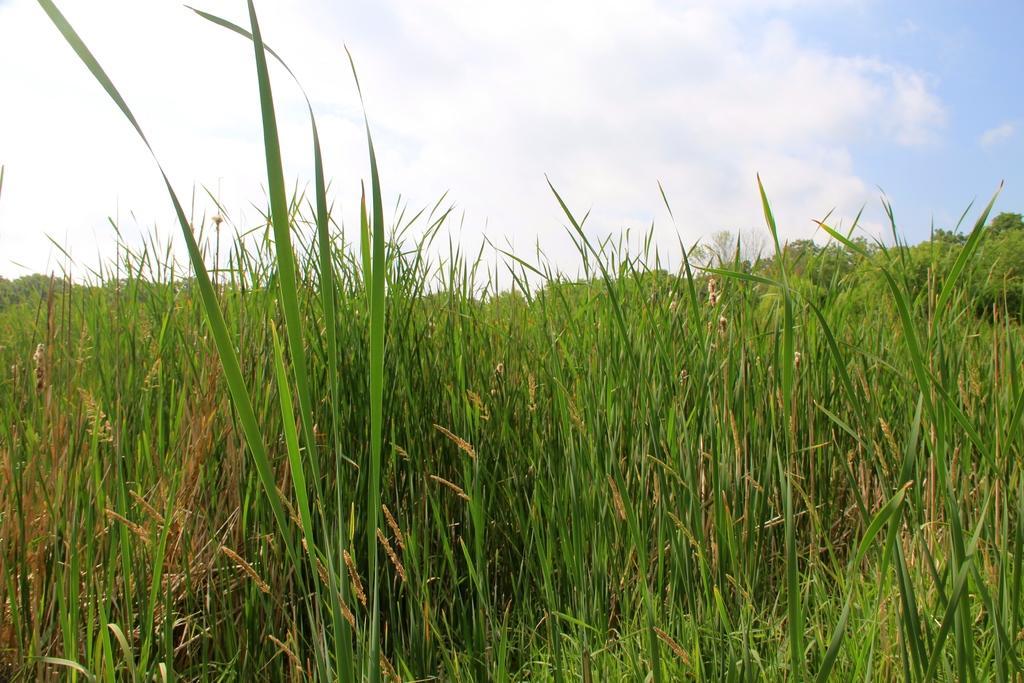Please provide a concise description of this image. In this picture we can see some grass from left to right. Sky is blue in color and cloudy. 